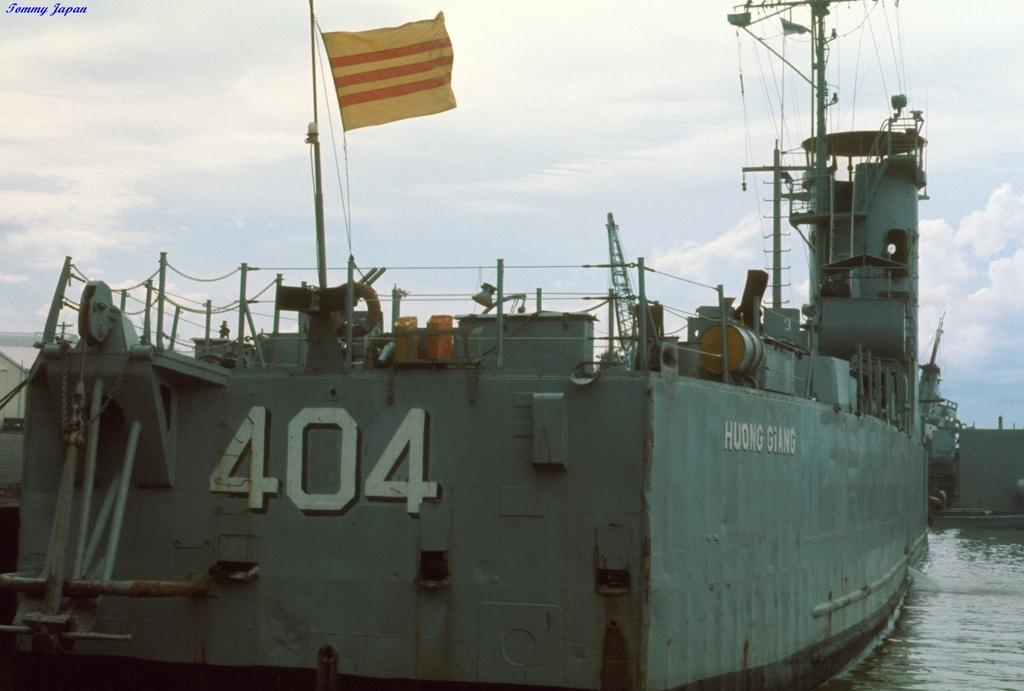What is the main subject of the image? The main subject of the image is a boat. What is located in the middle of the boat? There is a flag in the middle of the boat. What can be seen at the bottom of the image? There is water visible at the bottom of the image. What is visible at the top of the image? There is sky visible at the top of the image. What type of yoke is being used to control the boat in the image? There is no yoke present in the image, as boats are typically controlled using a steering wheel or tiller. 